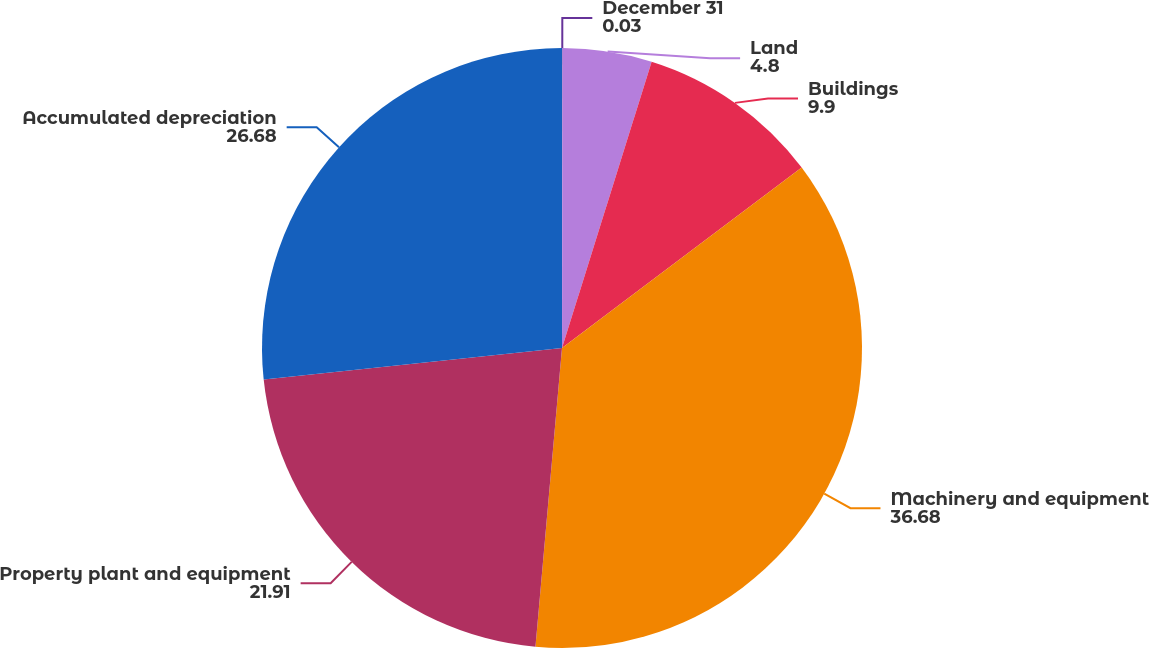<chart> <loc_0><loc_0><loc_500><loc_500><pie_chart><fcel>December 31<fcel>Land<fcel>Buildings<fcel>Machinery and equipment<fcel>Property plant and equipment<fcel>Accumulated depreciation<nl><fcel>0.03%<fcel>4.8%<fcel>9.9%<fcel>36.68%<fcel>21.91%<fcel>26.68%<nl></chart> 